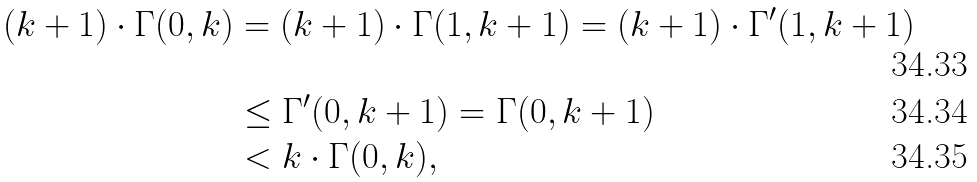Convert formula to latex. <formula><loc_0><loc_0><loc_500><loc_500>( k + 1 ) \cdot \Gamma ( 0 , k ) & = ( k + 1 ) \cdot \Gamma ( 1 , k + 1 ) = ( k + 1 ) \cdot \Gamma ^ { \prime } ( 1 , k + 1 ) \\ & \leq \Gamma ^ { \prime } ( 0 , k + 1 ) = \Gamma ( 0 , k + 1 ) \\ & < k \cdot \Gamma ( 0 , k ) ,</formula> 